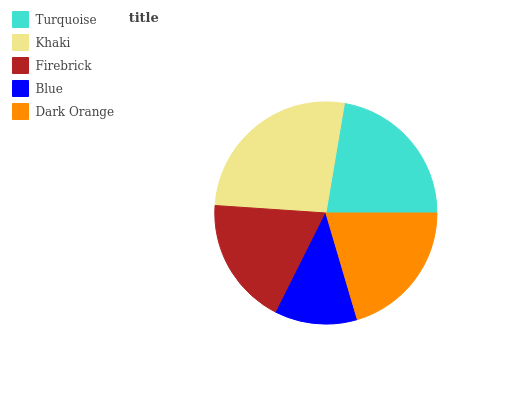Is Blue the minimum?
Answer yes or no. Yes. Is Khaki the maximum?
Answer yes or no. Yes. Is Firebrick the minimum?
Answer yes or no. No. Is Firebrick the maximum?
Answer yes or no. No. Is Khaki greater than Firebrick?
Answer yes or no. Yes. Is Firebrick less than Khaki?
Answer yes or no. Yes. Is Firebrick greater than Khaki?
Answer yes or no. No. Is Khaki less than Firebrick?
Answer yes or no. No. Is Dark Orange the high median?
Answer yes or no. Yes. Is Dark Orange the low median?
Answer yes or no. Yes. Is Turquoise the high median?
Answer yes or no. No. Is Firebrick the low median?
Answer yes or no. No. 